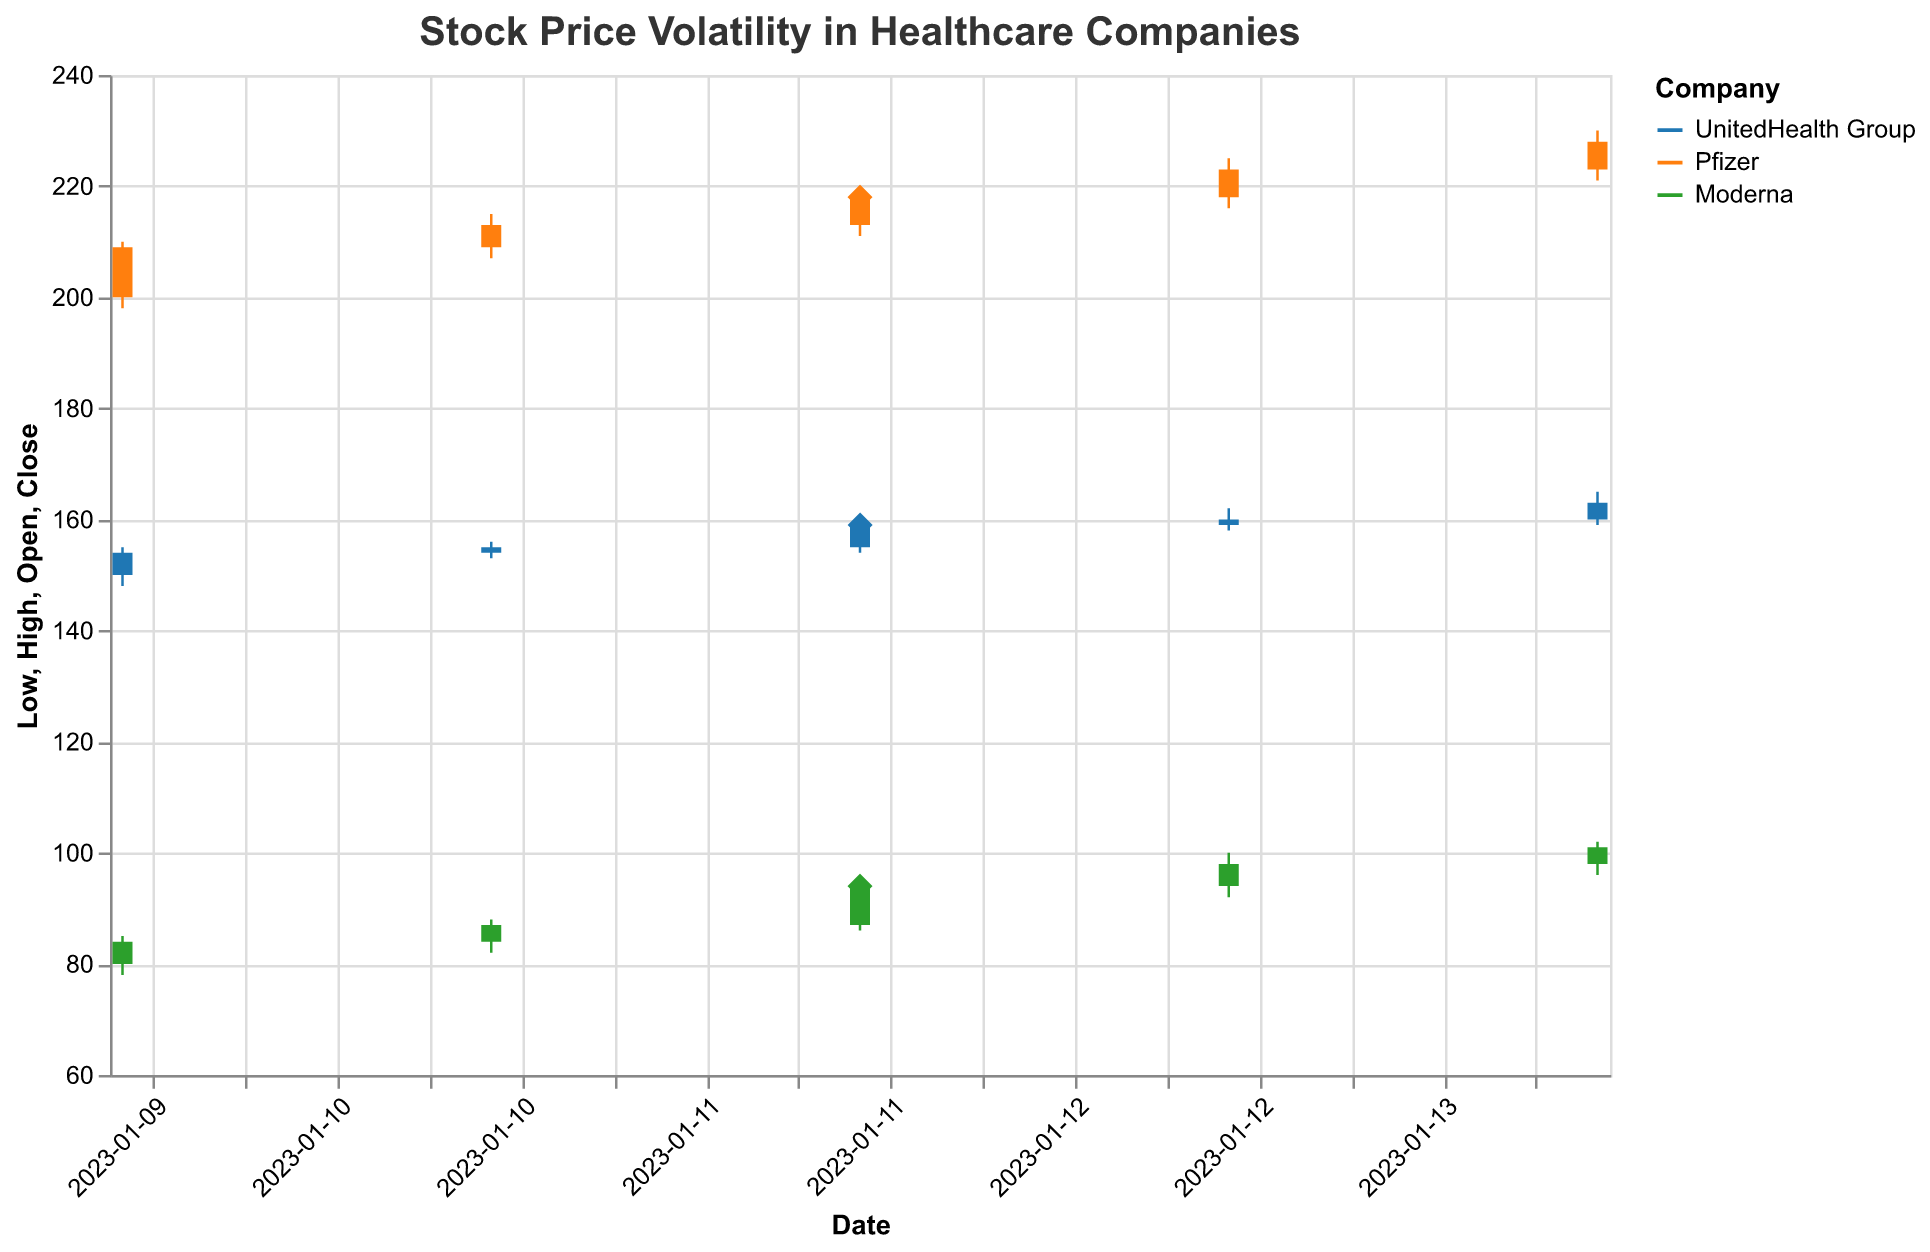How many health policy announcements were made during the given period? The plot indicates dates on which health policy announcements were made using diamond markers. By counting the diamond markers in the plot, we can determine the number of announcements. There are three diamond markers visible in the plot.
Answer: 3 Which company had the highest closing price on 2023-01-12? To find this, we need to look at the "Close" values for 2023-01-12. UnitedHealth Group's closing price was 159.00, Pfizer's was 218.00, and Moderna's was 94.00. Among these, Pfizer had the highest closing price.
Answer: Pfizer What was the average closing price of Moderna between 2023-01-10 and 2023-01-14? Calculate the average of Moderna's closing prices over the specified dates: (84.00 + 87.00 + 94.00 + 98.00 + 101.00) / 5 = 464 / 5 = 92.8
Answer: 92.8 Was there a significant increase in stock price for any company around January 12, 2023? Check the stock price before and after January 12, 2023, for significant changes. Moderna's stock price increased from 87.00 on January 11 to 94.00 on January 12 and further to 98.00 on January 13, indicating a significant increase.
Answer: Yes, Moderna Which company had the most volatility in stock prices on January 12, 2023? Volatility can be judged by the range between High and Low prices. On January 12, UnitedHealth Group's range was 6 (160 - 154), Pfizer's range was 9 (220 - 211), and Moderna's range was 9 (95 - 86). Pfizer and Moderna both had the highest volatility.
Answer: Pfizer and Moderna Did any company experience a price drop after January 12, 2023? Look at the closing prices before and after January 12, 2023. None of the companies (UnitedHealth Group, Pfizer, Moderna) experienced a price drop; all either maintained or increased their prices.
Answer: No Which company saw the highest trading volume on January 13, 2023? We check the "Volume" values for January 13, 2023. UnitedHealth Group had a volume of 1,400,000, Pfizer had 1,050,000, and Moderna had 2,400,000. Moderna had the highest trading volume on that day.
Answer: Moderna 